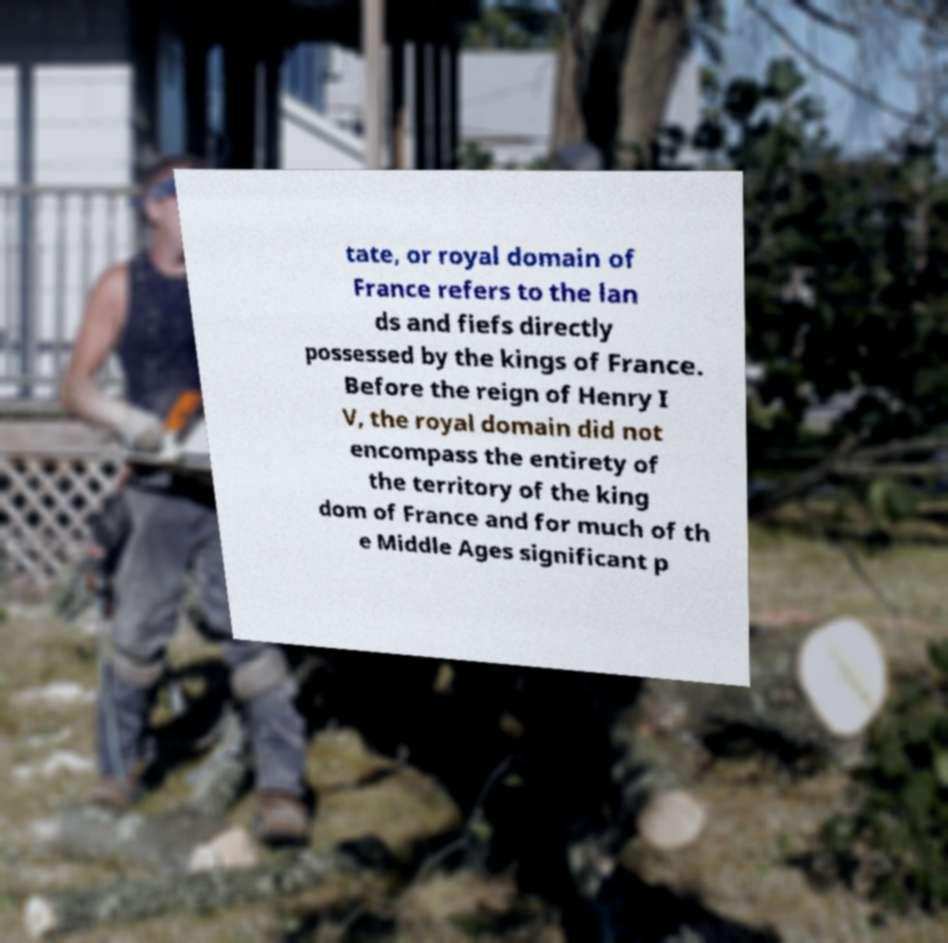Please identify and transcribe the text found in this image. tate, or royal domain of France refers to the lan ds and fiefs directly possessed by the kings of France. Before the reign of Henry I V, the royal domain did not encompass the entirety of the territory of the king dom of France and for much of th e Middle Ages significant p 